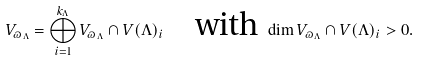Convert formula to latex. <formula><loc_0><loc_0><loc_500><loc_500>V _ { \varpi _ { \Lambda } } = \bigoplus _ { i = 1 } ^ { k _ { \Lambda } } V _ { \varpi _ { \Lambda } } \cap V ( \Lambda ) _ { i } \quad \text {with } \dim V _ { \varpi _ { \Lambda } } \cap V ( \Lambda ) _ { i } > 0 .</formula> 